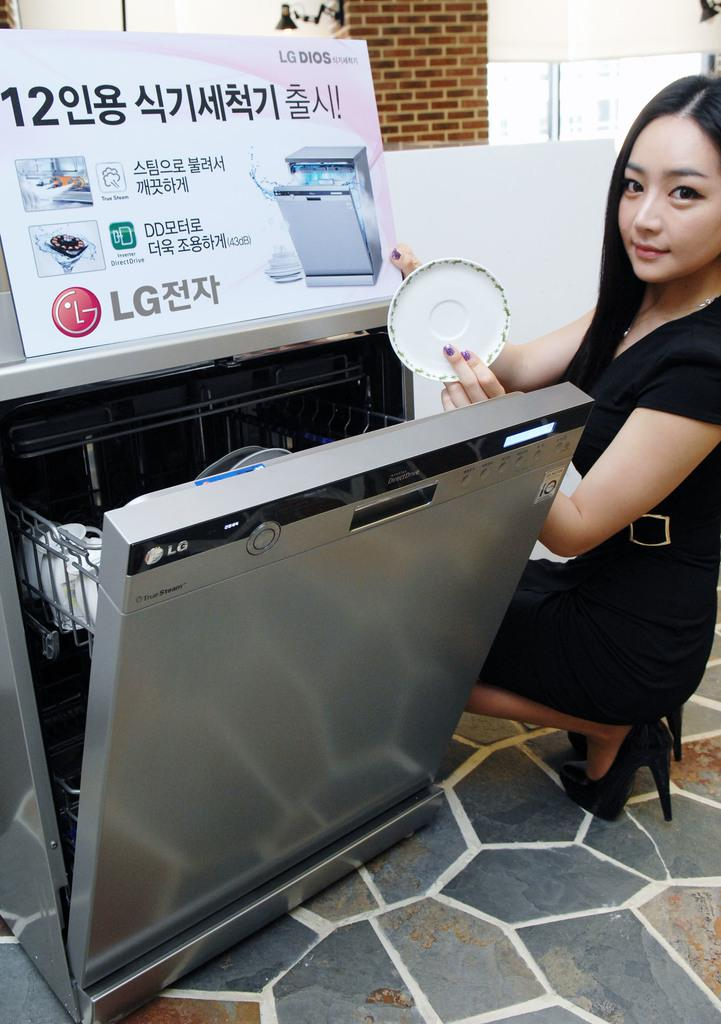<image>
Share a concise interpretation of the image provided. A woman holding up a plate and a sign advertising the brand of the dishwasher which is LG. 